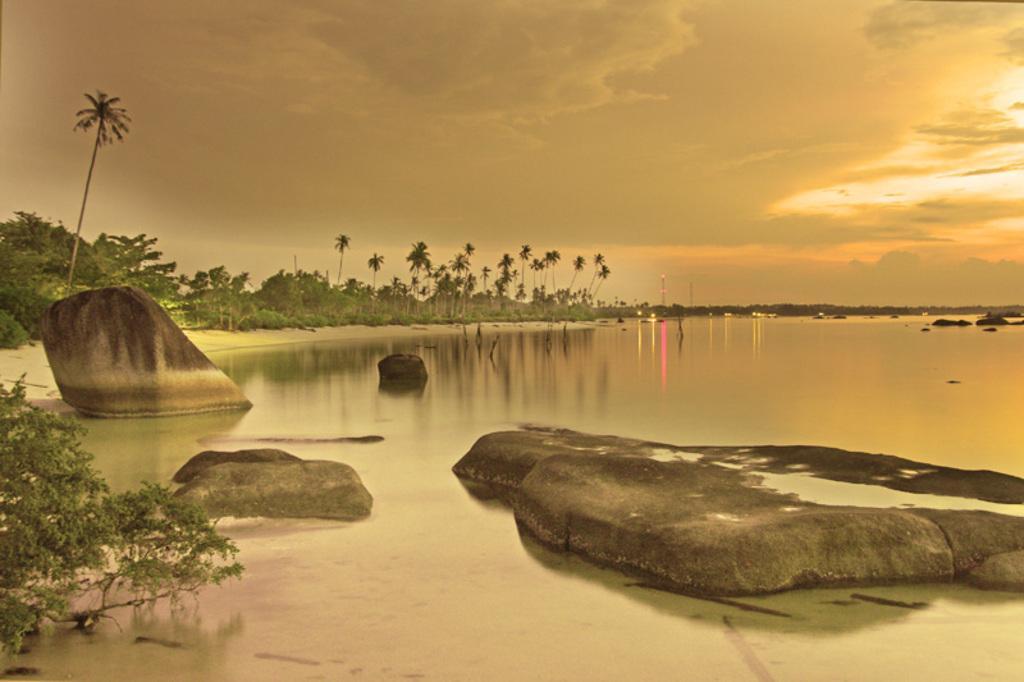In one or two sentences, can you explain what this image depicts? On the left side, there is a tree and there are rocks in the water. On the right side, there is a rock in the water. In the background, there are rocks in the water, there are trees and plants on the ground and there are clouds in the sky. 